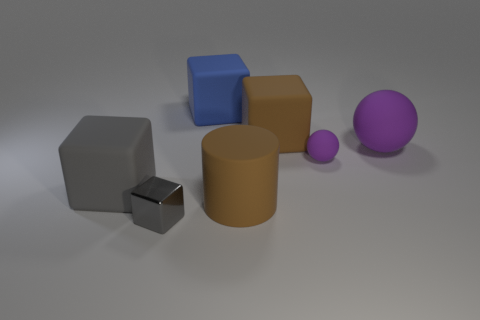What can you infer about the environment where these objects are placed? The objects are situated in a space with a plain, homogenous background, and the shadows cast by the objects suggest a single light source from above. This setting could indicate a controlled lighting environment, like a studio setup for a 3D model rendering or a similarly simulated scene. 